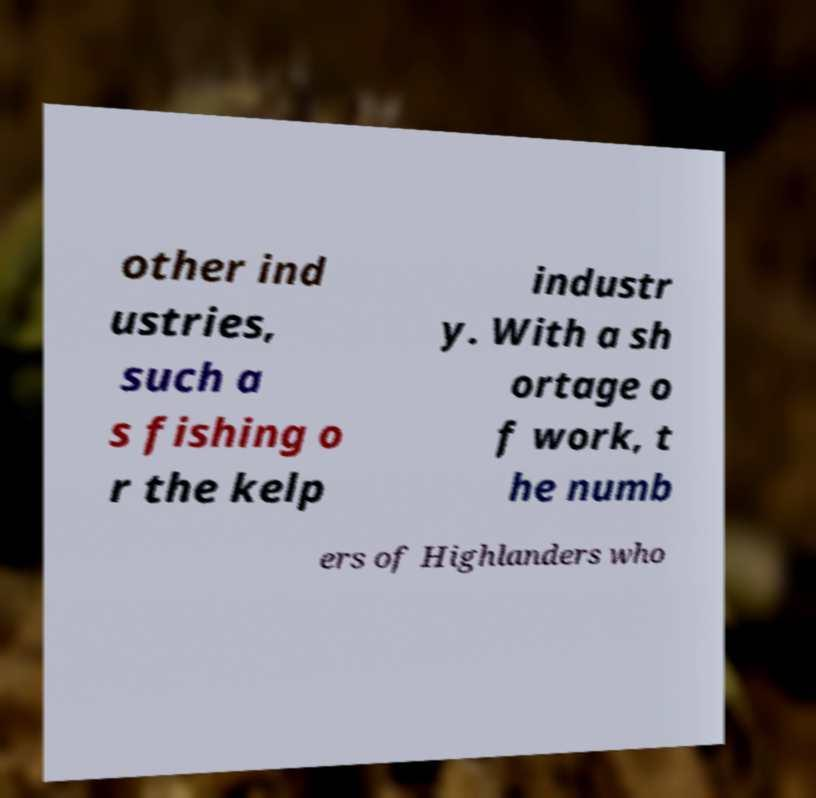Could you extract and type out the text from this image? other ind ustries, such a s fishing o r the kelp industr y. With a sh ortage o f work, t he numb ers of Highlanders who 